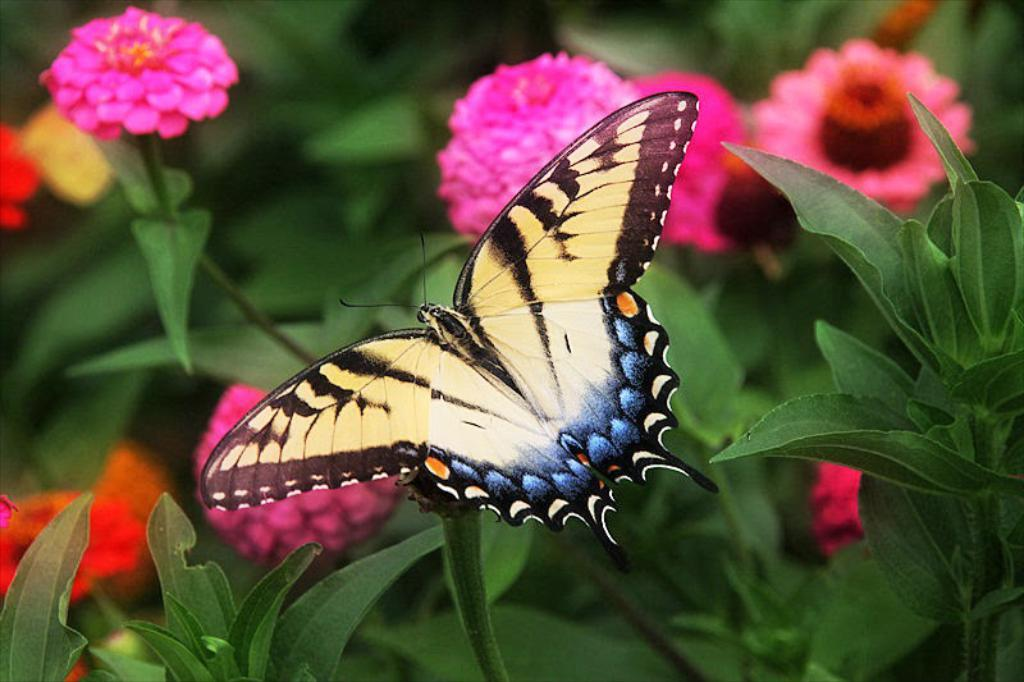What is the main subject of the image? There is a butterfly in the image. Where is the butterfly located? The butterfly is on a plant. What colors can be seen in the background of the image? In the background, there are flowers in pink and red colors, as well as green leaves. What type of cheese is being used for acoustics in the image? There is no cheese or acoustics present in the image; it features a butterfly on a plant with flowers and leaves in the background. 